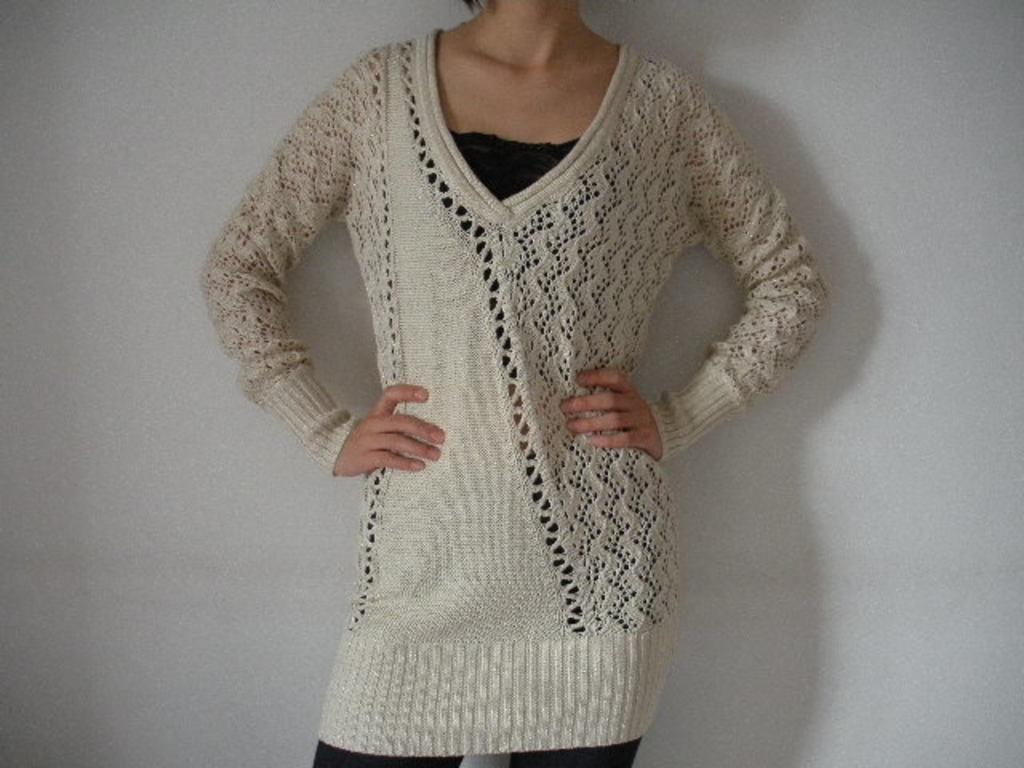In one or two sentences, can you explain what this image depicts? In this picture we can see a person wearing a white woolen top and standing. A wall is visible in the background. 